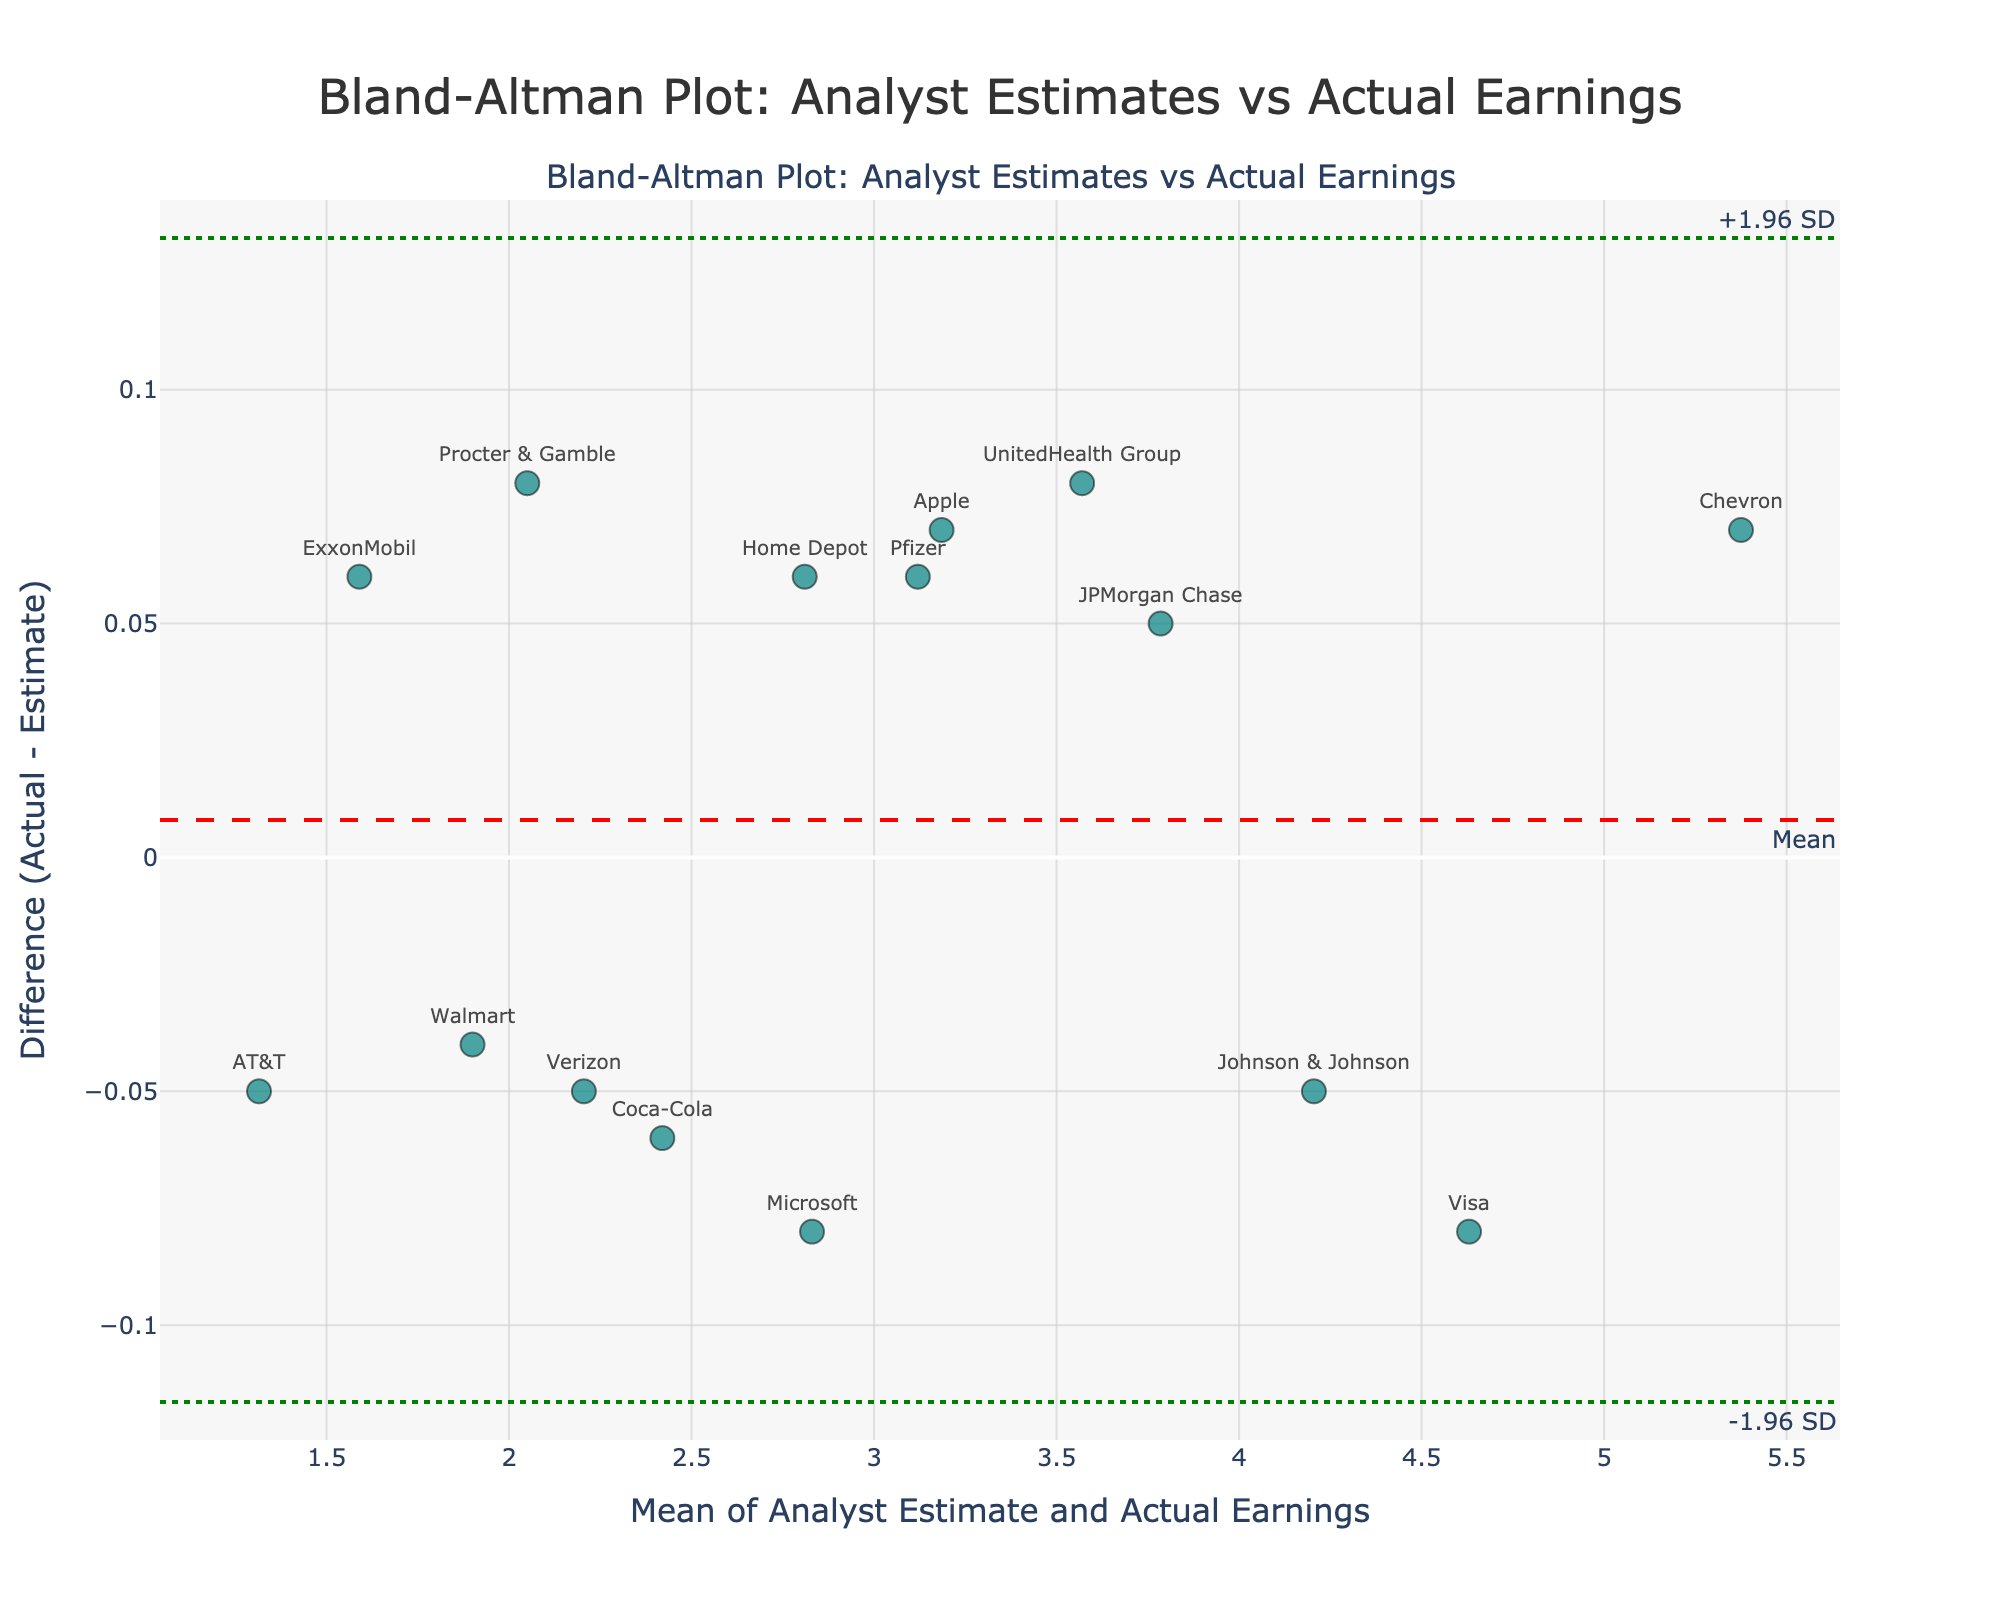What is the title of the plot? The title of the plot is displayed at the top of the figure and reads "Bland-Altman Plot: Analyst Estimates vs Actual Earnings".
Answer: Bland-Altman Plot: Analyst Estimates vs Actual Earnings What do the x-axis and y-axis represent? The x-axis represents the mean of analyst estimate and actual earnings, while the y-axis represents the difference between actual and estimate (Actual - Estimate). These labels are indicated along the axes.
Answer: The x-axis represents the mean of analyst estimate and actual earnings; the y-axis represents the difference (Actual - Estimate) How many companies are represented in the plot? Count the number of data points or markers in the plot. There are 15 companies listed in the data, each represented by a marker on the plot.
Answer: 15 What do the red and green dashed lines represent? The red dashed line represents the mean difference between the actual earnings and analyst estimates. The green dashed lines represent the limits of agreement, which are mean difference ± 1.96 standard deviations. These lines are labeled in the plot.
Answer: The red line represents the mean difference; the green lines represent ±1.96 standard deviations Which company has the largest positive difference between actual earnings and analyst estimates? Look for the company farthest above the horizontal zero line. Chevron has the largest positive difference.
Answer: Chevron Which company has the largest negative difference? Look for the company farthest below the horizontal zero line. Verizon has the largest negative difference.
Answer: Verizon What is the mean difference between actual earnings and analyst estimates? The red dashed line with the annotation "Mean" indicates the mean difference on the y-axis.
Answer: Mean difference Are most differences between actual earnings and estimates within the limits of agreement? Check if most data points fall between the two green dashed lines. Yes, most points fall within these limits.
Answer: Yes Does any company have an actual earning equal to its estimate? Check if any data point lies precisely on the horizontal zero line. No data point is on the zero line.
Answer: No What is the approximate range of the limits of agreement? The green dashed lines show the range of the limits on the y-axis. If we approximate, the lower limit is around -0.1 and the upper limit is around 0.1.
Answer: Approximately -0.1 to 0.1 